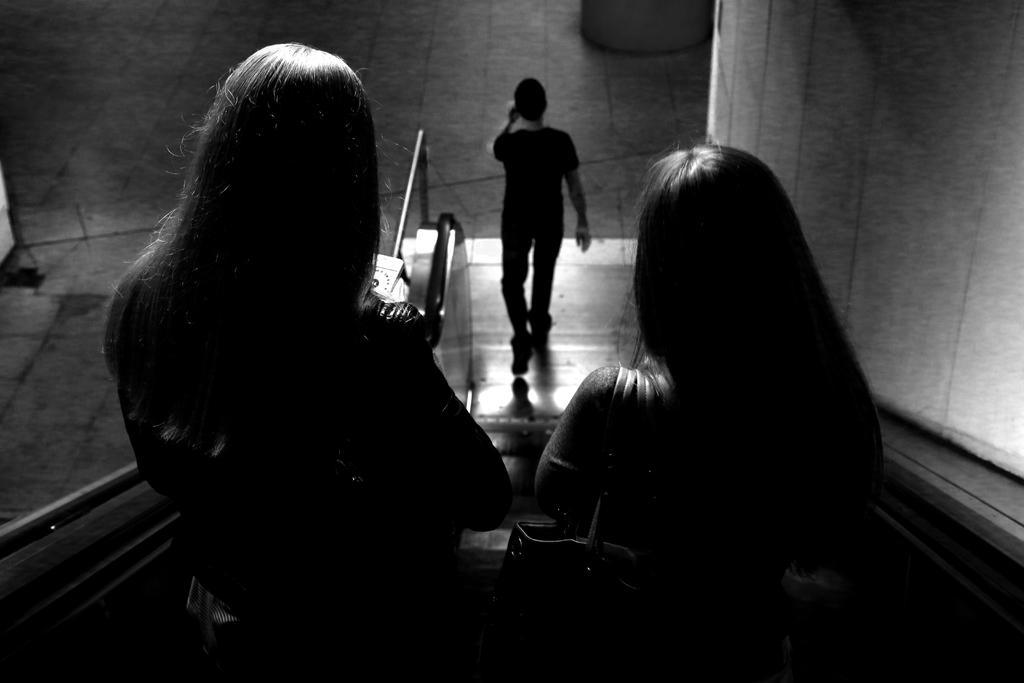Could you give a brief overview of what you see in this image? In this image we can see two people standing on the escalator and there is a man. We can see a wall. 